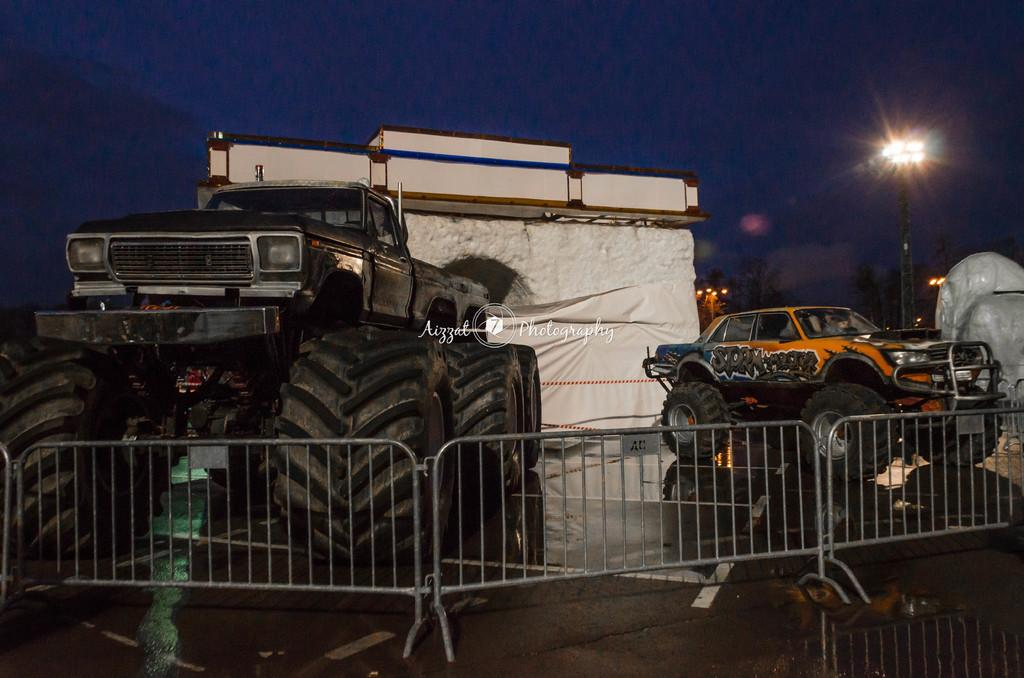What types of objects can be seen in the image? There are vehicles and lights in the image. Can you describe the surroundings or setting in the image? There is a railing in the image, which suggests a specific location or structure. Where is the sugar stored in the image? There is no sugar present in the image. What type of lunchroom can be seen in the image? There is no lunchroom present in the image. 